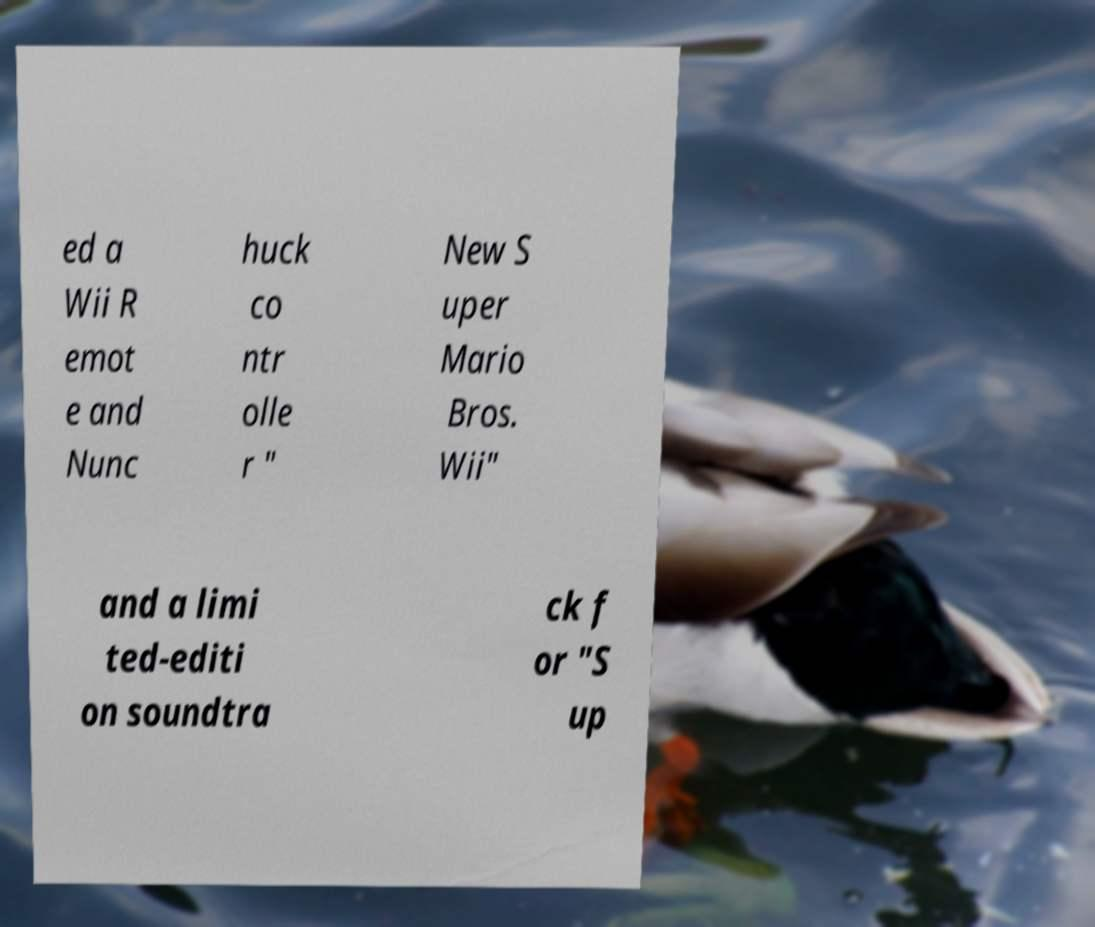There's text embedded in this image that I need extracted. Can you transcribe it verbatim? ed a Wii R emot e and Nunc huck co ntr olle r " New S uper Mario Bros. Wii" and a limi ted-editi on soundtra ck f or "S up 